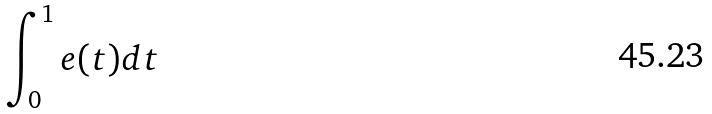<formula> <loc_0><loc_0><loc_500><loc_500>\int _ { 0 } ^ { 1 } e ( t ) d t</formula> 